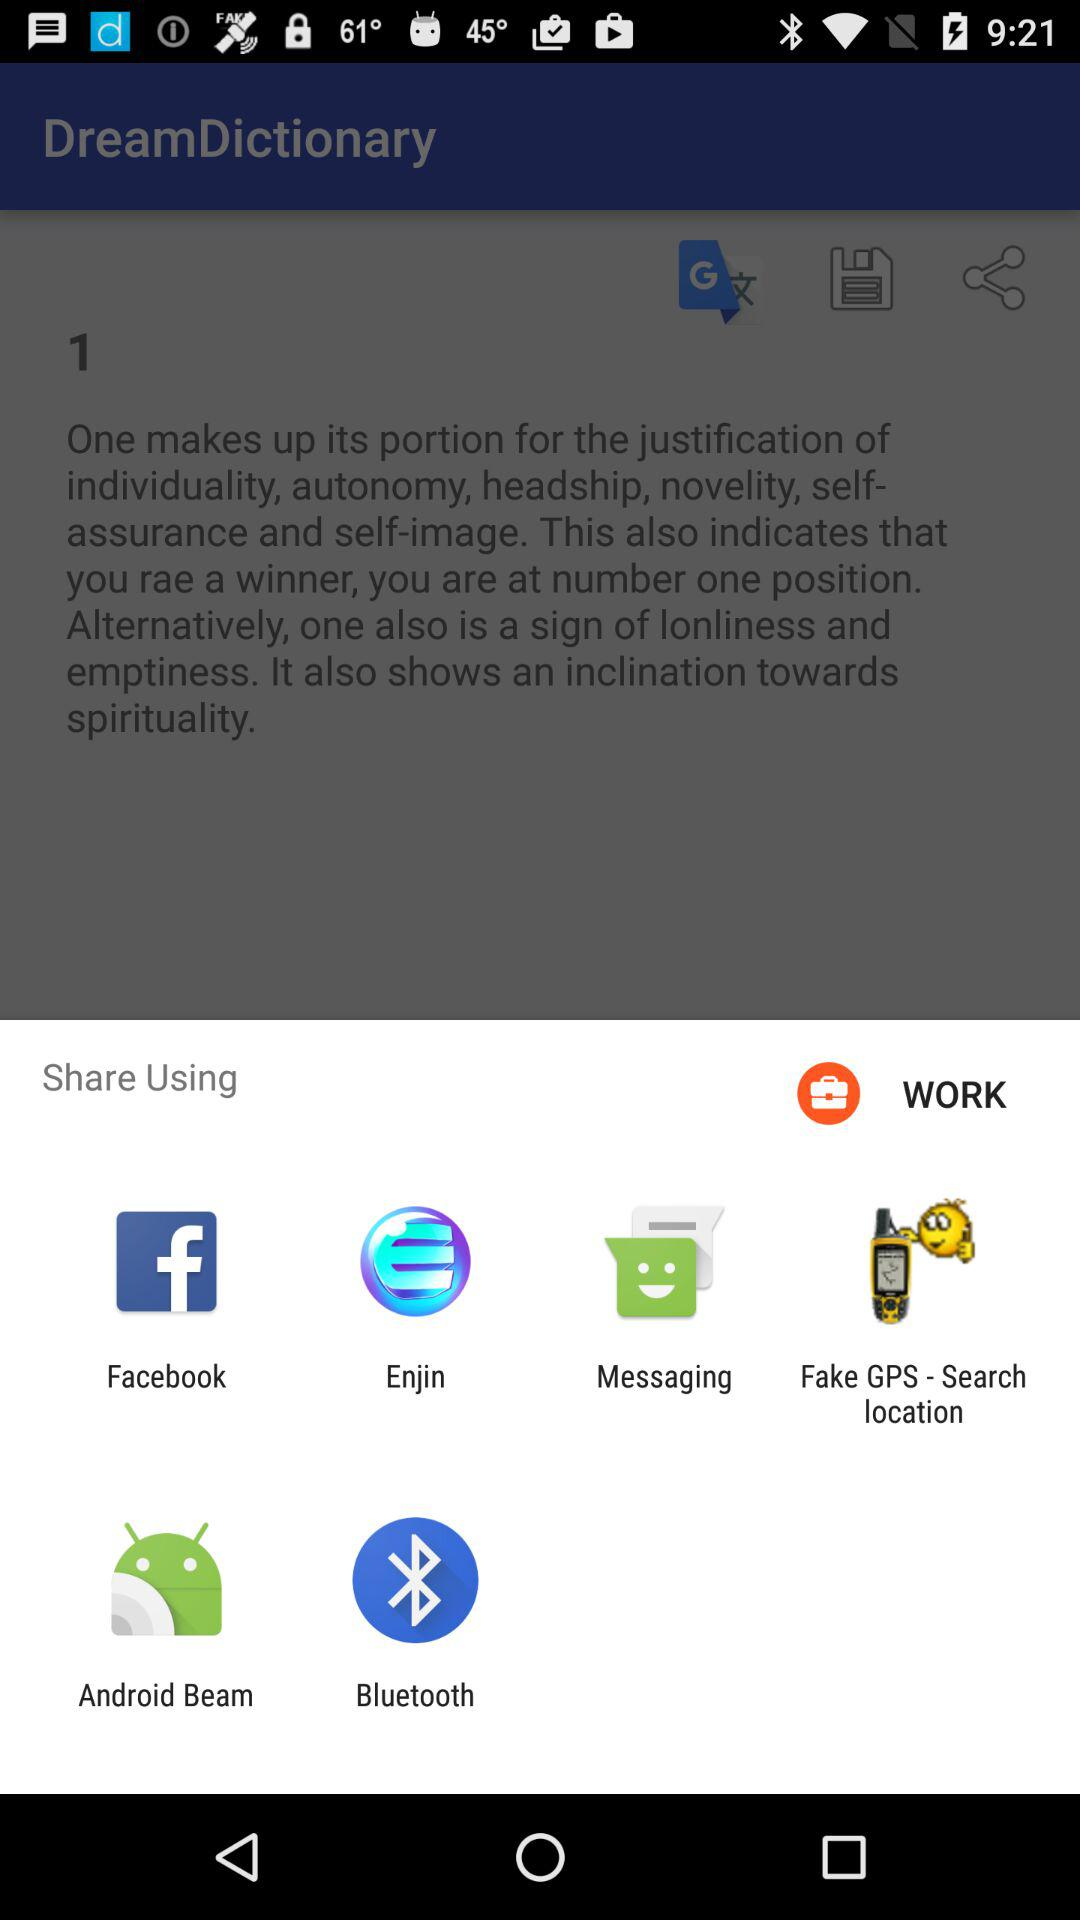What is the name of the application? The name of the application is "DreamDictionary". 